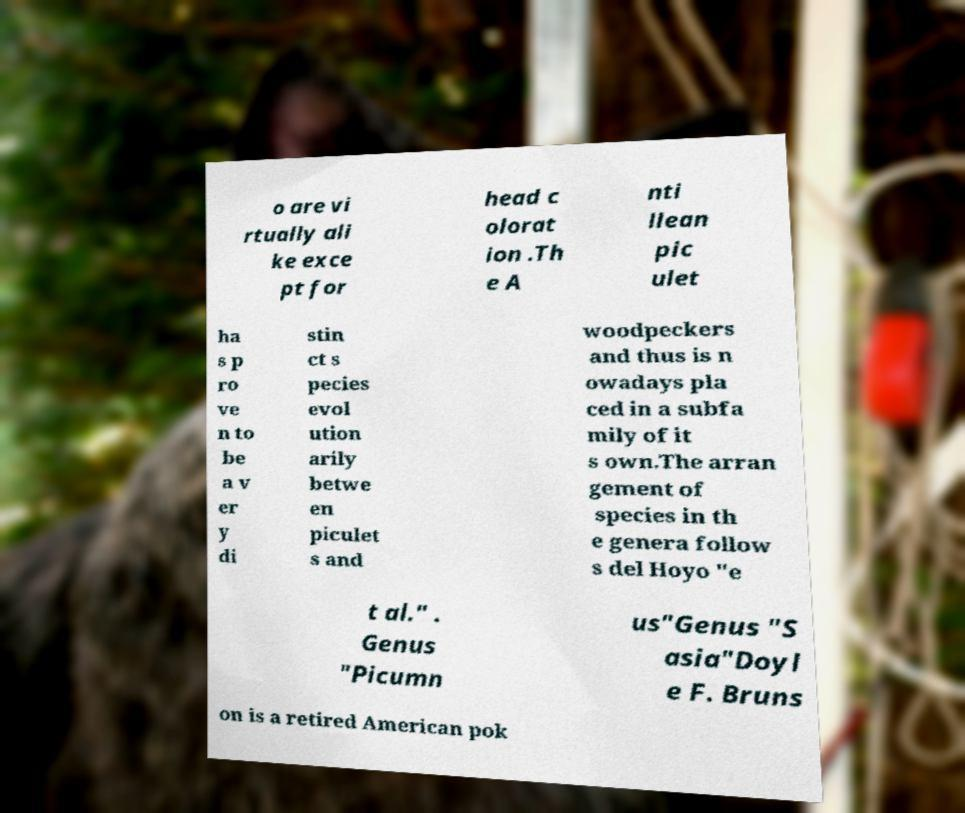Could you extract and type out the text from this image? o are vi rtually ali ke exce pt for head c olorat ion .Th e A nti llean pic ulet ha s p ro ve n to be a v er y di stin ct s pecies evol ution arily betwe en piculet s and woodpeckers and thus is n owadays pla ced in a subfa mily of it s own.The arran gement of species in th e genera follow s del Hoyo "e t al." . Genus "Picumn us"Genus "S asia"Doyl e F. Bruns on is a retired American pok 